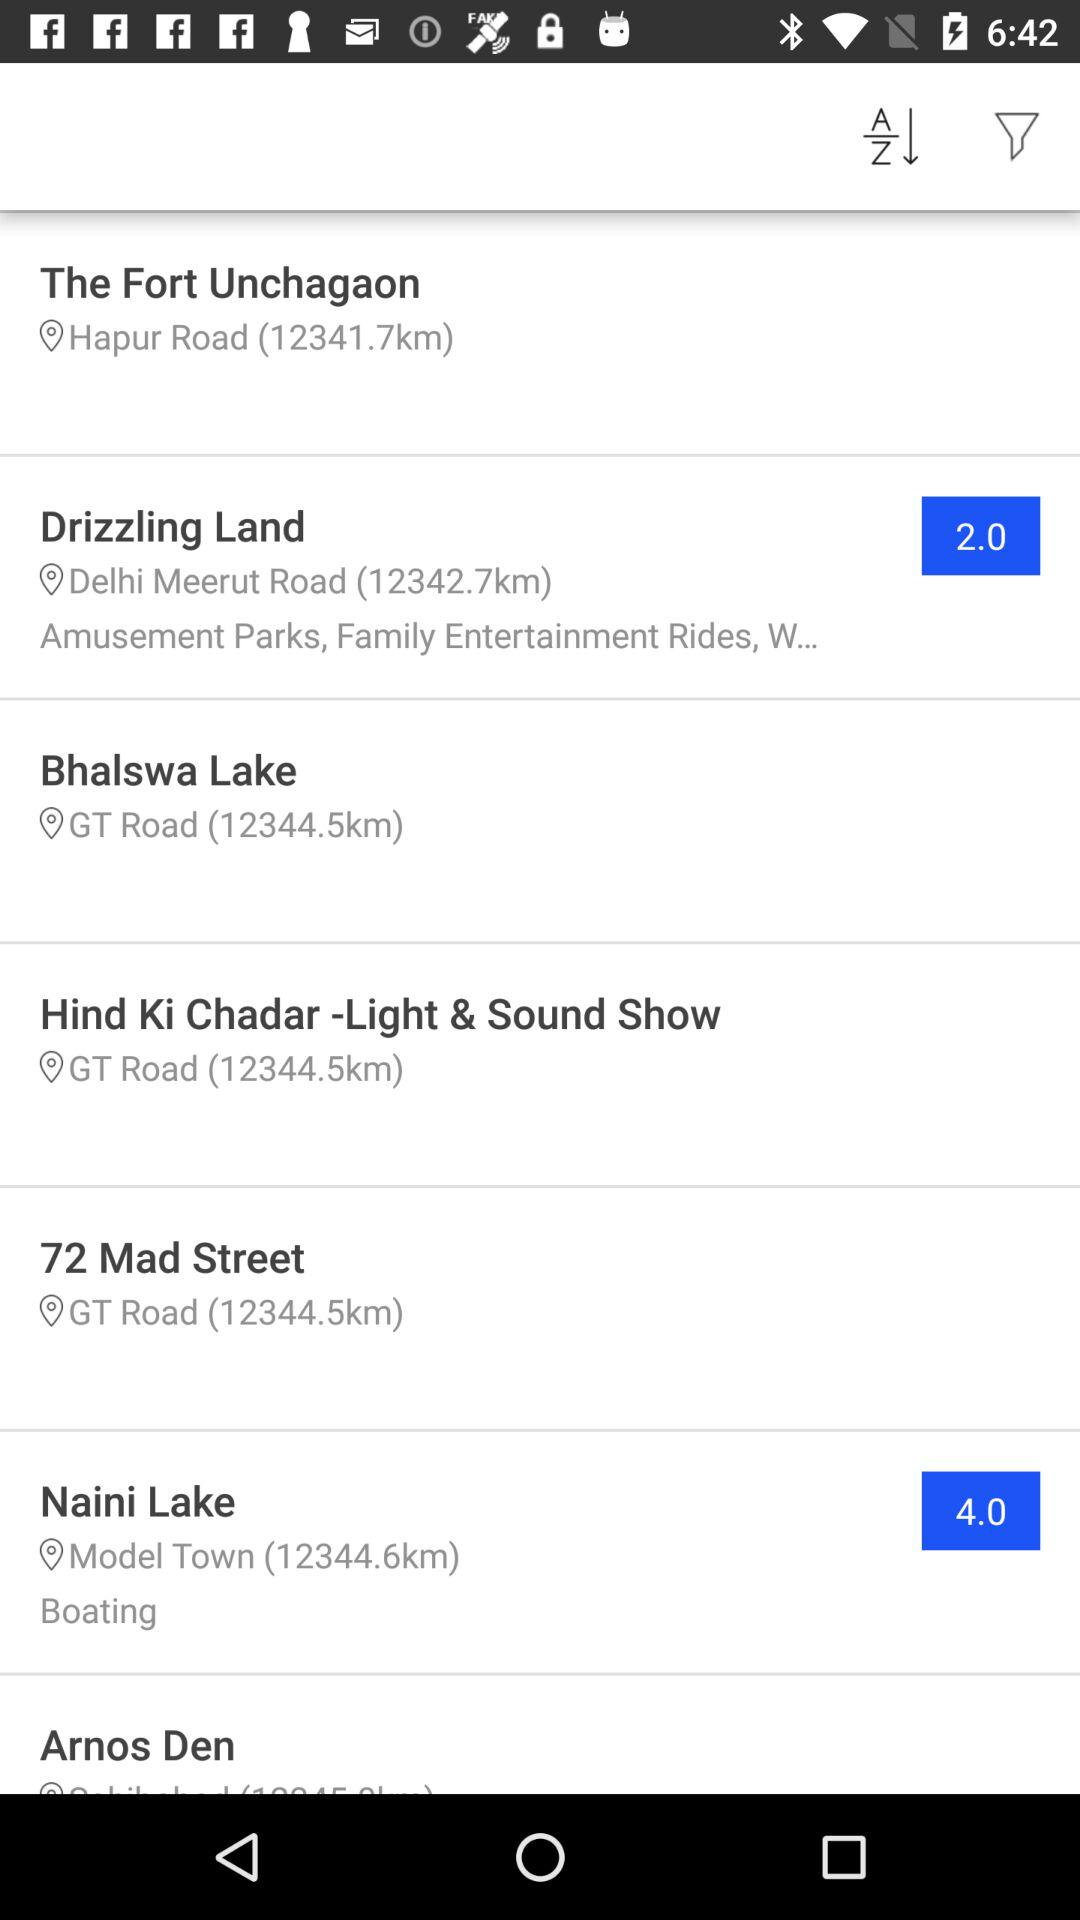Where is Fort Unchagaon? The Fort Unchagaon is on Hapur Road. 